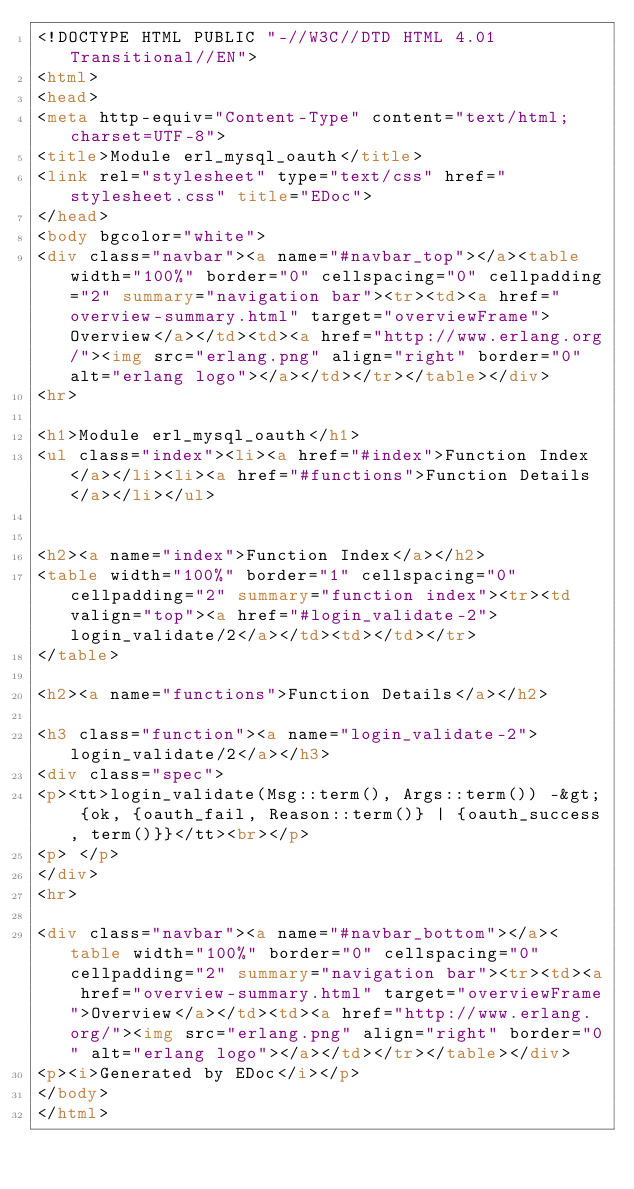Convert code to text. <code><loc_0><loc_0><loc_500><loc_500><_HTML_><!DOCTYPE HTML PUBLIC "-//W3C//DTD HTML 4.01 Transitional//EN">
<html>
<head>
<meta http-equiv="Content-Type" content="text/html; charset=UTF-8">
<title>Module erl_mysql_oauth</title>
<link rel="stylesheet" type="text/css" href="stylesheet.css" title="EDoc">
</head>
<body bgcolor="white">
<div class="navbar"><a name="#navbar_top"></a><table width="100%" border="0" cellspacing="0" cellpadding="2" summary="navigation bar"><tr><td><a href="overview-summary.html" target="overviewFrame">Overview</a></td><td><a href="http://www.erlang.org/"><img src="erlang.png" align="right" border="0" alt="erlang logo"></a></td></tr></table></div>
<hr>

<h1>Module erl_mysql_oauth</h1>
<ul class="index"><li><a href="#index">Function Index</a></li><li><a href="#functions">Function Details</a></li></ul>


<h2><a name="index">Function Index</a></h2>
<table width="100%" border="1" cellspacing="0" cellpadding="2" summary="function index"><tr><td valign="top"><a href="#login_validate-2">login_validate/2</a></td><td></td></tr>
</table>

<h2><a name="functions">Function Details</a></h2>

<h3 class="function"><a name="login_validate-2">login_validate/2</a></h3>
<div class="spec">
<p><tt>login_validate(Msg::term(), Args::term()) -&gt; {ok, {oauth_fail, Reason::term()} | {oauth_success, term()}}</tt><br></p>
<p> </p>
</div>
<hr>

<div class="navbar"><a name="#navbar_bottom"></a><table width="100%" border="0" cellspacing="0" cellpadding="2" summary="navigation bar"><tr><td><a href="overview-summary.html" target="overviewFrame">Overview</a></td><td><a href="http://www.erlang.org/"><img src="erlang.png" align="right" border="0" alt="erlang logo"></a></td></tr></table></div>
<p><i>Generated by EDoc</i></p>
</body>
</html>
</code> 